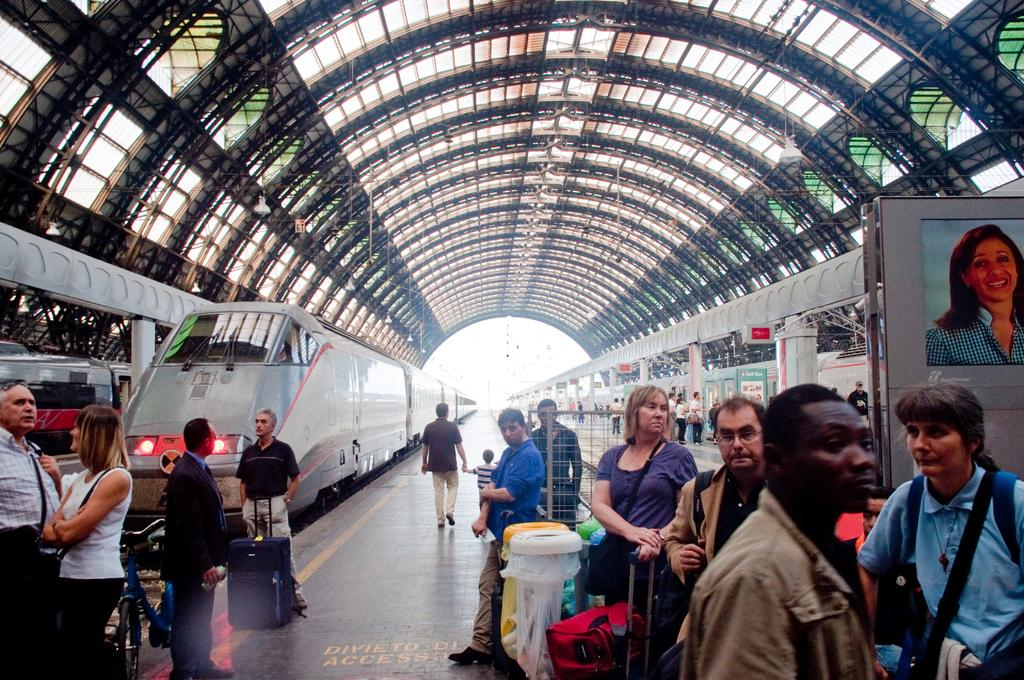What is the main subject of the image? The main subject of the image is a train on the track. Can you describe the people visible in the image? There are people visible in the image, but their specific actions or characteristics are not mentioned in the facts. What items can be seen in the image besides the train? There are bags, a screen, lights, boards, and a roof visible in the image. What type of jam is being spread on the bread in the image? There is no bread or jam present in the image; it features a train on the track and other items mentioned in the facts. 